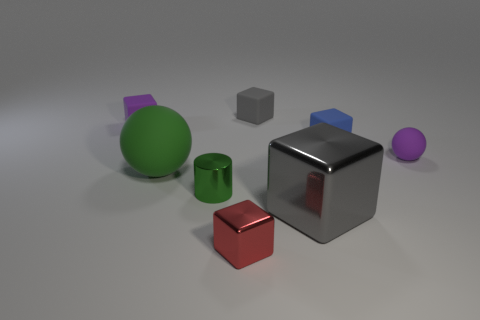Subtract all small blue cubes. How many cubes are left? 4 Add 1 green matte balls. How many objects exist? 9 Subtract all red cubes. How many cubes are left? 4 Subtract all blocks. How many objects are left? 3 Subtract all purple cylinders. How many gray blocks are left? 2 Add 5 green rubber objects. How many green rubber objects are left? 6 Add 1 large gray metal things. How many large gray metal things exist? 2 Subtract 0 brown spheres. How many objects are left? 8 Subtract 4 cubes. How many cubes are left? 1 Subtract all cyan cylinders. Subtract all blue spheres. How many cylinders are left? 1 